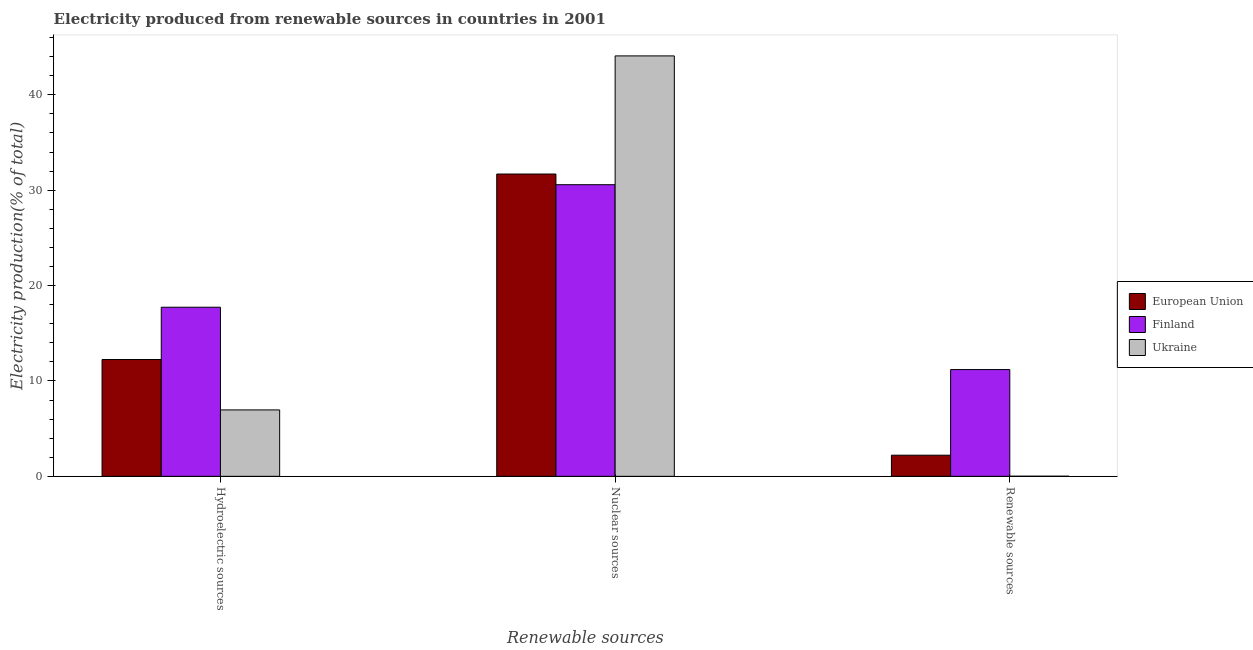How many groups of bars are there?
Your response must be concise. 3. Are the number of bars on each tick of the X-axis equal?
Give a very brief answer. Yes. How many bars are there on the 2nd tick from the right?
Your answer should be compact. 3. What is the label of the 3rd group of bars from the left?
Ensure brevity in your answer.  Renewable sources. What is the percentage of electricity produced by nuclear sources in Ukraine?
Keep it short and to the point. 44.08. Across all countries, what is the maximum percentage of electricity produced by hydroelectric sources?
Give a very brief answer. 17.73. Across all countries, what is the minimum percentage of electricity produced by nuclear sources?
Offer a very short reply. 30.57. In which country was the percentage of electricity produced by renewable sources maximum?
Keep it short and to the point. Finland. In which country was the percentage of electricity produced by nuclear sources minimum?
Your answer should be compact. Finland. What is the total percentage of electricity produced by nuclear sources in the graph?
Offer a terse response. 106.35. What is the difference between the percentage of electricity produced by renewable sources in Ukraine and that in Finland?
Your response must be concise. -11.18. What is the difference between the percentage of electricity produced by renewable sources in Finland and the percentage of electricity produced by hydroelectric sources in European Union?
Provide a succinct answer. -1.05. What is the average percentage of electricity produced by nuclear sources per country?
Provide a short and direct response. 35.45. What is the difference between the percentage of electricity produced by renewable sources and percentage of electricity produced by hydroelectric sources in European Union?
Give a very brief answer. -10.03. In how many countries, is the percentage of electricity produced by renewable sources greater than 20 %?
Provide a succinct answer. 0. What is the ratio of the percentage of electricity produced by nuclear sources in Ukraine to that in European Union?
Offer a terse response. 1.39. Is the percentage of electricity produced by nuclear sources in Finland less than that in European Union?
Your answer should be very brief. Yes. What is the difference between the highest and the second highest percentage of electricity produced by nuclear sources?
Your response must be concise. 12.39. What is the difference between the highest and the lowest percentage of electricity produced by renewable sources?
Provide a succinct answer. 11.18. In how many countries, is the percentage of electricity produced by nuclear sources greater than the average percentage of electricity produced by nuclear sources taken over all countries?
Give a very brief answer. 1. Is the sum of the percentage of electricity produced by hydroelectric sources in European Union and Finland greater than the maximum percentage of electricity produced by nuclear sources across all countries?
Offer a terse response. No. What does the 3rd bar from the left in Hydroelectric sources represents?
Offer a very short reply. Ukraine. Is it the case that in every country, the sum of the percentage of electricity produced by hydroelectric sources and percentage of electricity produced by nuclear sources is greater than the percentage of electricity produced by renewable sources?
Offer a terse response. Yes. Are all the bars in the graph horizontal?
Your answer should be compact. No. How many countries are there in the graph?
Offer a very short reply. 3. Does the graph contain any zero values?
Provide a succinct answer. No. Does the graph contain grids?
Ensure brevity in your answer.  No. How are the legend labels stacked?
Provide a short and direct response. Vertical. What is the title of the graph?
Your response must be concise. Electricity produced from renewable sources in countries in 2001. What is the label or title of the X-axis?
Provide a short and direct response. Renewable sources. What is the label or title of the Y-axis?
Ensure brevity in your answer.  Electricity production(% of total). What is the Electricity production(% of total) of European Union in Hydroelectric sources?
Offer a terse response. 12.24. What is the Electricity production(% of total) in Finland in Hydroelectric sources?
Your answer should be very brief. 17.73. What is the Electricity production(% of total) in Ukraine in Hydroelectric sources?
Give a very brief answer. 6.96. What is the Electricity production(% of total) in European Union in Nuclear sources?
Give a very brief answer. 31.69. What is the Electricity production(% of total) of Finland in Nuclear sources?
Your response must be concise. 30.57. What is the Electricity production(% of total) of Ukraine in Nuclear sources?
Offer a very short reply. 44.08. What is the Electricity production(% of total) in European Union in Renewable sources?
Provide a succinct answer. 2.21. What is the Electricity production(% of total) of Finland in Renewable sources?
Your answer should be very brief. 11.19. What is the Electricity production(% of total) in Ukraine in Renewable sources?
Offer a very short reply. 0.01. Across all Renewable sources, what is the maximum Electricity production(% of total) in European Union?
Provide a short and direct response. 31.69. Across all Renewable sources, what is the maximum Electricity production(% of total) of Finland?
Keep it short and to the point. 30.57. Across all Renewable sources, what is the maximum Electricity production(% of total) of Ukraine?
Offer a terse response. 44.08. Across all Renewable sources, what is the minimum Electricity production(% of total) in European Union?
Offer a terse response. 2.21. Across all Renewable sources, what is the minimum Electricity production(% of total) in Finland?
Make the answer very short. 11.19. Across all Renewable sources, what is the minimum Electricity production(% of total) of Ukraine?
Your response must be concise. 0.01. What is the total Electricity production(% of total) of European Union in the graph?
Provide a short and direct response. 46.15. What is the total Electricity production(% of total) of Finland in the graph?
Make the answer very short. 59.5. What is the total Electricity production(% of total) in Ukraine in the graph?
Your answer should be very brief. 51.05. What is the difference between the Electricity production(% of total) in European Union in Hydroelectric sources and that in Nuclear sources?
Your response must be concise. -19.45. What is the difference between the Electricity production(% of total) in Finland in Hydroelectric sources and that in Nuclear sources?
Offer a terse response. -12.85. What is the difference between the Electricity production(% of total) in Ukraine in Hydroelectric sources and that in Nuclear sources?
Your answer should be very brief. -37.12. What is the difference between the Electricity production(% of total) of European Union in Hydroelectric sources and that in Renewable sources?
Keep it short and to the point. 10.03. What is the difference between the Electricity production(% of total) of Finland in Hydroelectric sources and that in Renewable sources?
Provide a short and direct response. 6.54. What is the difference between the Electricity production(% of total) in Ukraine in Hydroelectric sources and that in Renewable sources?
Ensure brevity in your answer.  6.95. What is the difference between the Electricity production(% of total) in European Union in Nuclear sources and that in Renewable sources?
Keep it short and to the point. 29.48. What is the difference between the Electricity production(% of total) of Finland in Nuclear sources and that in Renewable sources?
Offer a very short reply. 19.38. What is the difference between the Electricity production(% of total) of Ukraine in Nuclear sources and that in Renewable sources?
Ensure brevity in your answer.  44.07. What is the difference between the Electricity production(% of total) of European Union in Hydroelectric sources and the Electricity production(% of total) of Finland in Nuclear sources?
Your response must be concise. -18.33. What is the difference between the Electricity production(% of total) in European Union in Hydroelectric sources and the Electricity production(% of total) in Ukraine in Nuclear sources?
Give a very brief answer. -31.83. What is the difference between the Electricity production(% of total) of Finland in Hydroelectric sources and the Electricity production(% of total) of Ukraine in Nuclear sources?
Provide a short and direct response. -26.35. What is the difference between the Electricity production(% of total) of European Union in Hydroelectric sources and the Electricity production(% of total) of Finland in Renewable sources?
Make the answer very short. 1.05. What is the difference between the Electricity production(% of total) in European Union in Hydroelectric sources and the Electricity production(% of total) in Ukraine in Renewable sources?
Offer a terse response. 12.24. What is the difference between the Electricity production(% of total) in Finland in Hydroelectric sources and the Electricity production(% of total) in Ukraine in Renewable sources?
Your answer should be compact. 17.72. What is the difference between the Electricity production(% of total) in European Union in Nuclear sources and the Electricity production(% of total) in Finland in Renewable sources?
Provide a short and direct response. 20.5. What is the difference between the Electricity production(% of total) in European Union in Nuclear sources and the Electricity production(% of total) in Ukraine in Renewable sources?
Your answer should be compact. 31.68. What is the difference between the Electricity production(% of total) of Finland in Nuclear sources and the Electricity production(% of total) of Ukraine in Renewable sources?
Your response must be concise. 30.57. What is the average Electricity production(% of total) in European Union per Renewable sources?
Make the answer very short. 15.38. What is the average Electricity production(% of total) of Finland per Renewable sources?
Provide a succinct answer. 19.83. What is the average Electricity production(% of total) of Ukraine per Renewable sources?
Keep it short and to the point. 17.02. What is the difference between the Electricity production(% of total) of European Union and Electricity production(% of total) of Finland in Hydroelectric sources?
Offer a very short reply. -5.48. What is the difference between the Electricity production(% of total) of European Union and Electricity production(% of total) of Ukraine in Hydroelectric sources?
Make the answer very short. 5.28. What is the difference between the Electricity production(% of total) in Finland and Electricity production(% of total) in Ukraine in Hydroelectric sources?
Ensure brevity in your answer.  10.77. What is the difference between the Electricity production(% of total) of European Union and Electricity production(% of total) of Finland in Nuclear sources?
Your answer should be compact. 1.12. What is the difference between the Electricity production(% of total) in European Union and Electricity production(% of total) in Ukraine in Nuclear sources?
Your response must be concise. -12.38. What is the difference between the Electricity production(% of total) in Finland and Electricity production(% of total) in Ukraine in Nuclear sources?
Your answer should be very brief. -13.5. What is the difference between the Electricity production(% of total) of European Union and Electricity production(% of total) of Finland in Renewable sources?
Provide a short and direct response. -8.98. What is the difference between the Electricity production(% of total) in European Union and Electricity production(% of total) in Ukraine in Renewable sources?
Keep it short and to the point. 2.21. What is the difference between the Electricity production(% of total) in Finland and Electricity production(% of total) in Ukraine in Renewable sources?
Offer a terse response. 11.18. What is the ratio of the Electricity production(% of total) in European Union in Hydroelectric sources to that in Nuclear sources?
Give a very brief answer. 0.39. What is the ratio of the Electricity production(% of total) of Finland in Hydroelectric sources to that in Nuclear sources?
Provide a short and direct response. 0.58. What is the ratio of the Electricity production(% of total) in Ukraine in Hydroelectric sources to that in Nuclear sources?
Your answer should be compact. 0.16. What is the ratio of the Electricity production(% of total) in European Union in Hydroelectric sources to that in Renewable sources?
Keep it short and to the point. 5.53. What is the ratio of the Electricity production(% of total) of Finland in Hydroelectric sources to that in Renewable sources?
Make the answer very short. 1.58. What is the ratio of the Electricity production(% of total) of Ukraine in Hydroelectric sources to that in Renewable sources?
Offer a very short reply. 752. What is the ratio of the Electricity production(% of total) in European Union in Nuclear sources to that in Renewable sources?
Give a very brief answer. 14.31. What is the ratio of the Electricity production(% of total) of Finland in Nuclear sources to that in Renewable sources?
Make the answer very short. 2.73. What is the ratio of the Electricity production(% of total) in Ukraine in Nuclear sources to that in Renewable sources?
Your response must be concise. 4760.56. What is the difference between the highest and the second highest Electricity production(% of total) of European Union?
Your answer should be compact. 19.45. What is the difference between the highest and the second highest Electricity production(% of total) in Finland?
Ensure brevity in your answer.  12.85. What is the difference between the highest and the second highest Electricity production(% of total) of Ukraine?
Give a very brief answer. 37.12. What is the difference between the highest and the lowest Electricity production(% of total) of European Union?
Provide a succinct answer. 29.48. What is the difference between the highest and the lowest Electricity production(% of total) in Finland?
Offer a terse response. 19.38. What is the difference between the highest and the lowest Electricity production(% of total) in Ukraine?
Provide a short and direct response. 44.07. 